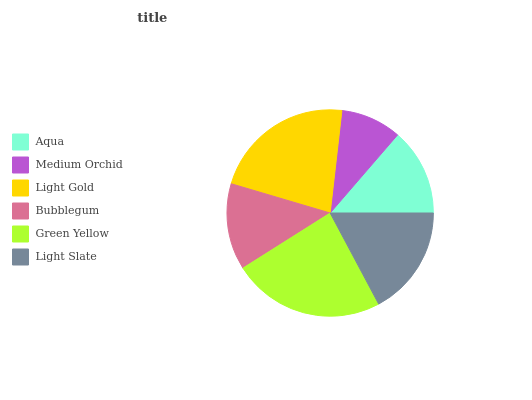Is Medium Orchid the minimum?
Answer yes or no. Yes. Is Green Yellow the maximum?
Answer yes or no. Yes. Is Light Gold the minimum?
Answer yes or no. No. Is Light Gold the maximum?
Answer yes or no. No. Is Light Gold greater than Medium Orchid?
Answer yes or no. Yes. Is Medium Orchid less than Light Gold?
Answer yes or no. Yes. Is Medium Orchid greater than Light Gold?
Answer yes or no. No. Is Light Gold less than Medium Orchid?
Answer yes or no. No. Is Light Slate the high median?
Answer yes or no. Yes. Is Aqua the low median?
Answer yes or no. Yes. Is Light Gold the high median?
Answer yes or no. No. Is Medium Orchid the low median?
Answer yes or no. No. 